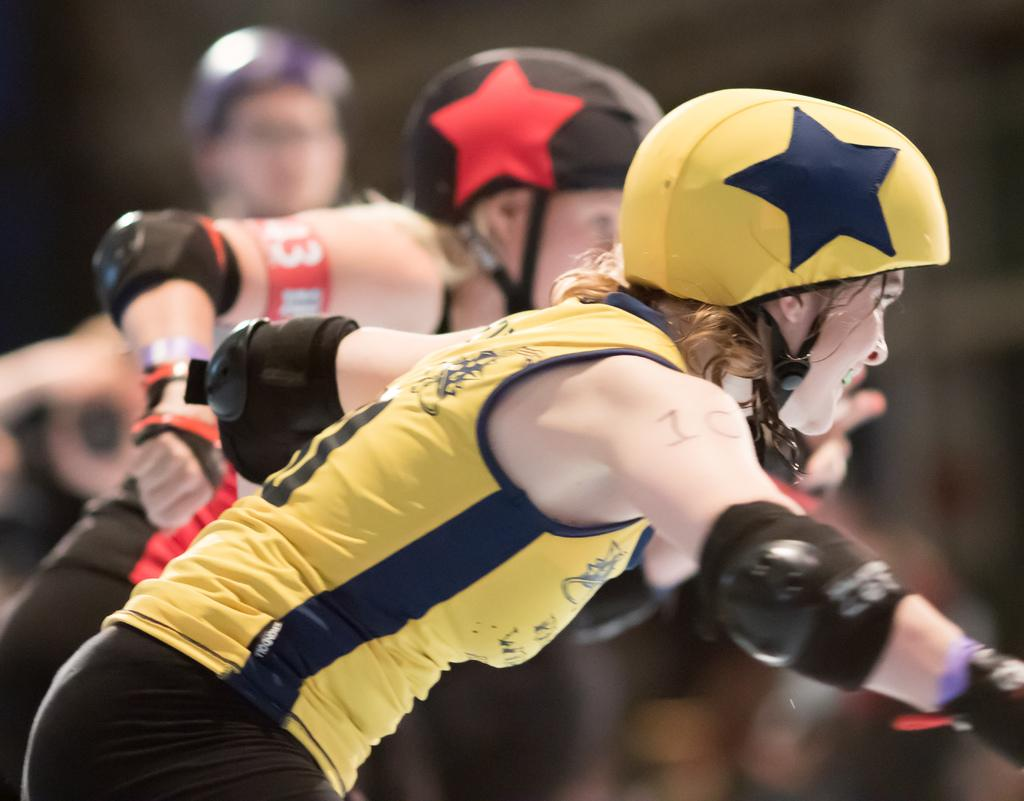Who or what is present in the image? There are people in the image. What are the people wearing on their heads? The people are wearing helmets. Can you describe the background of the image? The background of the image is blurred. What is the value of the ticket that the people are holding in the image? There is no ticket present in the image, so it is not possible to determine its value. 